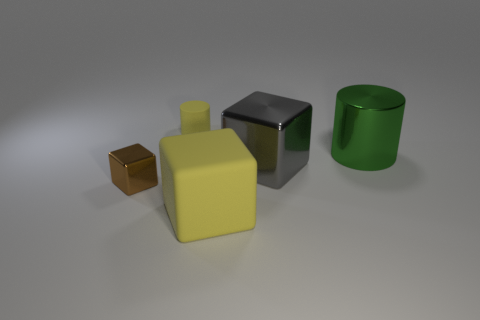How many small rubber cylinders are the same color as the large metal block?
Your response must be concise. 0. How many objects are yellow matte cylinders or objects that are right of the small yellow matte cylinder?
Provide a short and direct response. 4. What color is the tiny shiny thing?
Keep it short and to the point. Brown. What color is the tiny thing that is in front of the large green cylinder?
Provide a succinct answer. Brown. There is a large thing behind the gray metallic cube; how many green cylinders are to the right of it?
Your response must be concise. 0. Is the size of the brown metal object the same as the yellow thing that is in front of the small brown shiny object?
Make the answer very short. No. Are there any other yellow blocks that have the same size as the yellow cube?
Your answer should be very brief. No. What number of objects are gray objects or big things?
Keep it short and to the point. 3. Do the matte object that is in front of the small brown object and the metallic thing right of the large gray metal thing have the same size?
Ensure brevity in your answer.  Yes. Are there any tiny yellow rubber objects of the same shape as the large green object?
Ensure brevity in your answer.  Yes. 